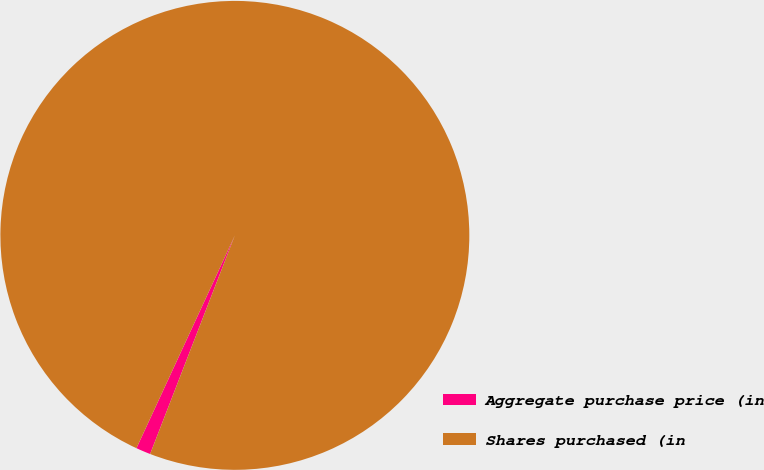Convert chart. <chart><loc_0><loc_0><loc_500><loc_500><pie_chart><fcel>Aggregate purchase price (in<fcel>Shares purchased (in<nl><fcel>1.01%<fcel>98.99%<nl></chart> 